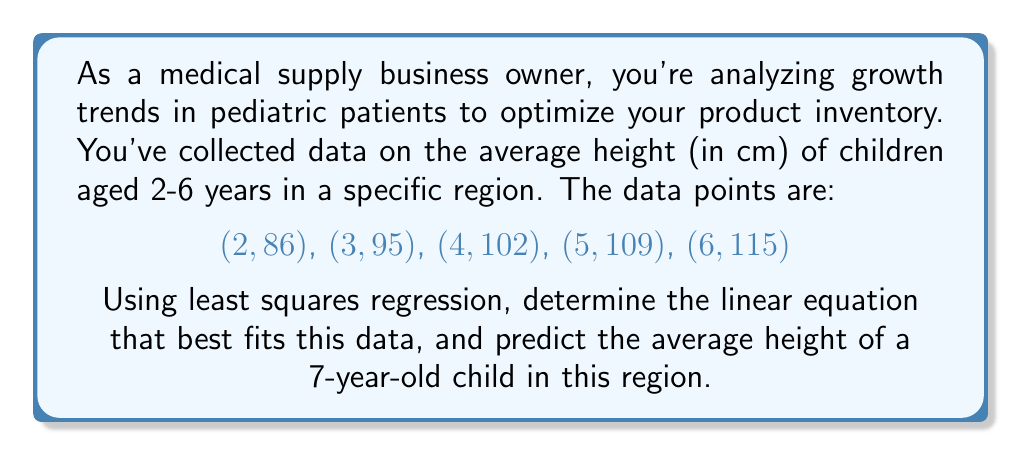Give your solution to this math problem. Let's approach this step-by-step using least squares regression:

1) We have n = 5 data points. Let x represent age and y represent height.

2) Calculate the sums we need:
   $$\sum x = 2 + 3 + 4 + 5 + 6 = 20$$
   $$\sum y = 86 + 95 + 102 + 109 + 115 = 507$$
   $$\sum x^2 = 4 + 9 + 16 + 25 + 36 = 90$$
   $$\sum xy = 172 + 285 + 408 + 545 + 690 = 2100$$

3) Use the least squares formulas to find the slope (m) and y-intercept (b):

   $$m = \frac{n\sum xy - \sum x \sum y}{n\sum x^2 - (\sum x)^2}$$
   $$m = \frac{5(2100) - 20(507)}{5(90) - 20^2} = \frac{10500 - 10140}{450 - 400} = \frac{360}{50} = 7.2$$

   $$b = \frac{\sum y - m\sum x}{n}$$
   $$b = \frac{507 - 7.2(20)}{5} = \frac{507 - 144}{5} = 72.6$$

4) The linear equation is:
   $$y = 7.2x + 72.6$$

5) To predict the height of a 7-year-old, substitute x = 7:
   $$y = 7.2(7) + 72.6 = 50.4 + 72.6 = 123$$

Therefore, the predicted average height of a 7-year-old child is 123 cm.
Answer: y = 7.2x + 72.6; 123 cm 